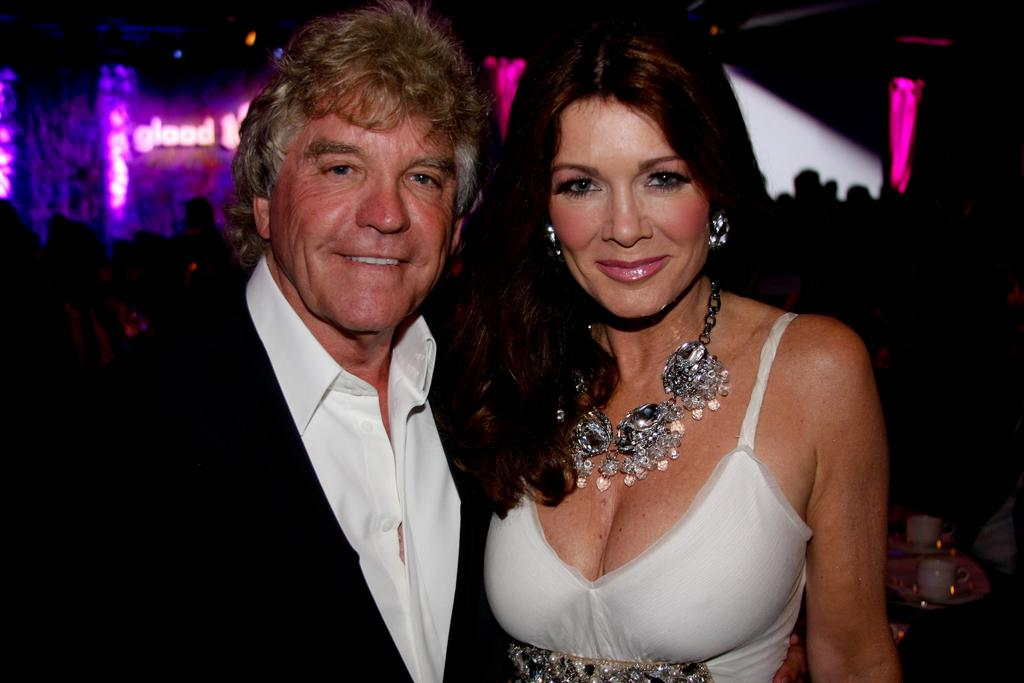Who are the two people standing in the image? There is a man and a woman standing in the image. What objects can be seen on plates in the background? There are cups on plates in the background. What else can be seen in the background of the image? There is a group of people standing in the background, as well as lights and text on a wall. How many bikes are parked in front of the wall with text in the image? There are no bikes visible in the image. What type of sign is present in the image? There is no sign present in the image; there is only text on a wall in the background. 